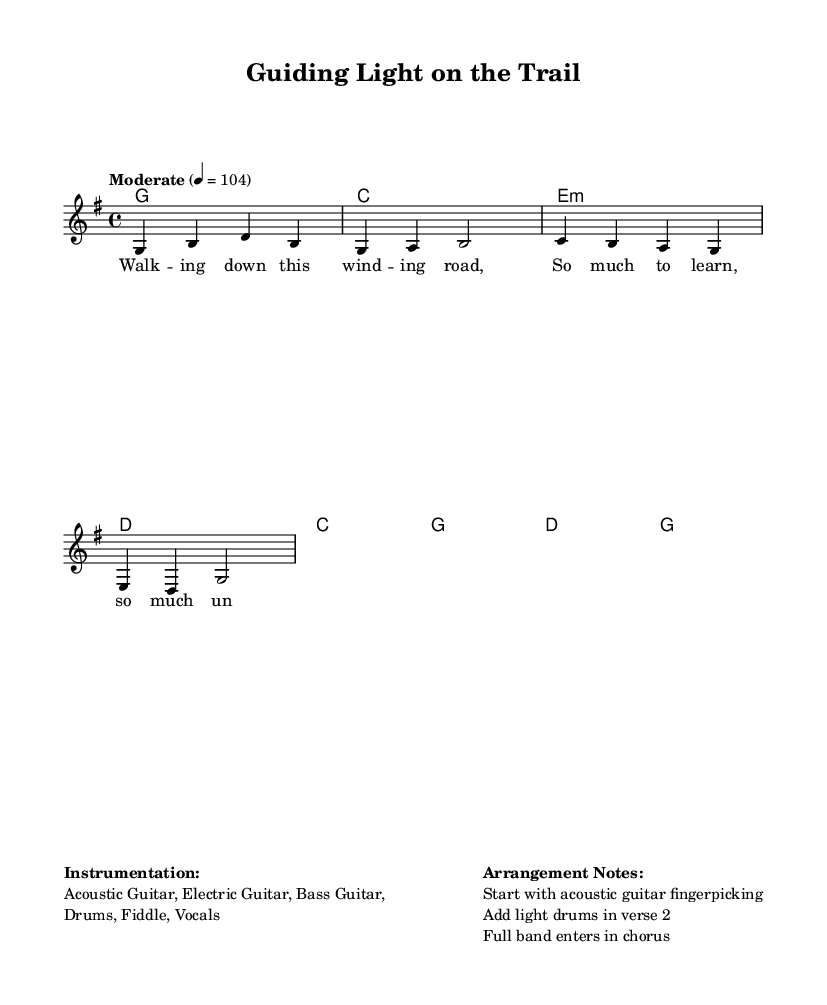What is the key signature of this music? The key signature is G major, which has one sharp (F#). This is indicated at the beginning of the staff before the notes start.
Answer: G major What is the time signature of this piece? The time signature is 4/4, as shown at the beginning of the music. This indicates there are four beats in each measure, and the quarter note gets one beat.
Answer: 4/4 What is the tempo marking for this piece? The tempo marking is "Moderate" with a tempo of 104 beats per minute. This indicates how fast the piece should be played.
Answer: Moderate 104 What instruments are specified for this arrangement? The instrumentation listed includes Acoustic Guitar, Electric Guitar, Bass Guitar, Drums, Fiddle, and Vocals. This is provided in the markup section at the end of the score.
Answer: Acoustic Guitar, Electric Guitar, Bass Guitar, Drums, Fiddle, Vocals What do the lyrics of the chorus emphasize? The lyrics of the chorus emphasize guidance and support. The phrase “You're the light that leads us on” highlights the importance of mentorship in navigating challenges.
Answer: Guidance and support How does the arrangement evolve from the verse to the chorus? The arrangement starts with acoustic guitar fingerpicking in the verse and adds light drums in the second verse before the full band enters in the chorus, creating a dynamic transition that enhances the message of support.
Answer: Evolving dynamics What is the primary theme conveyed in the lyrics of the song? The primary theme conveyed in the lyrics is the importance of mentorship and guidance during life's journey, capturing the essence of a supportive relationship.
Answer: Mentorship and guidance 